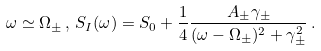Convert formula to latex. <formula><loc_0><loc_0><loc_500><loc_500>\omega \simeq \Omega _ { \pm } \, , \, S _ { I } ( \omega ) = S _ { 0 } + \frac { 1 } { 4 } \frac { A _ { \pm } \gamma _ { \pm } } { ( \omega - \Omega _ { \pm } ) ^ { 2 } + \gamma _ { \pm } ^ { 2 } } \, .</formula> 